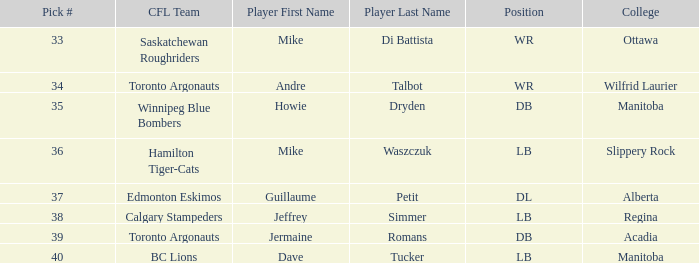What College has a Player that is jermaine romans? Acadia. 